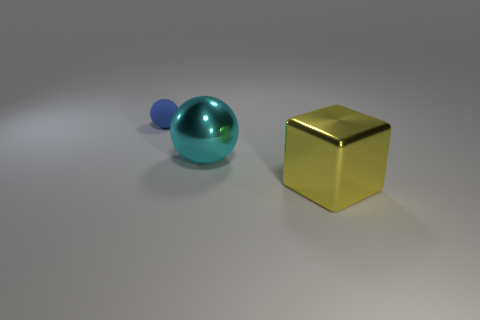What is the size of the thing that is both behind the large cube and in front of the matte sphere?
Offer a very short reply. Large. There is a shiny thing on the left side of the yellow metal block; is it the same shape as the tiny matte thing?
Provide a short and direct response. Yes. There is a thing that is on the left side of the large metallic thing that is behind the big metallic block in front of the cyan object; what is its size?
Offer a very short reply. Small. What number of objects are either yellow blocks or small yellow shiny blocks?
Offer a very short reply. 1. What shape is the thing that is both to the left of the yellow block and to the right of the tiny rubber object?
Your answer should be compact. Sphere. Do the blue matte thing and the shiny object behind the large shiny cube have the same shape?
Provide a short and direct response. Yes. There is a tiny thing; are there any small things right of it?
Give a very brief answer. No. What number of cubes are blue shiny objects or metal things?
Ensure brevity in your answer.  1. Do the cyan metal object and the small thing have the same shape?
Provide a short and direct response. Yes. What size is the cyan metallic thing behind the cube?
Offer a terse response. Large. 